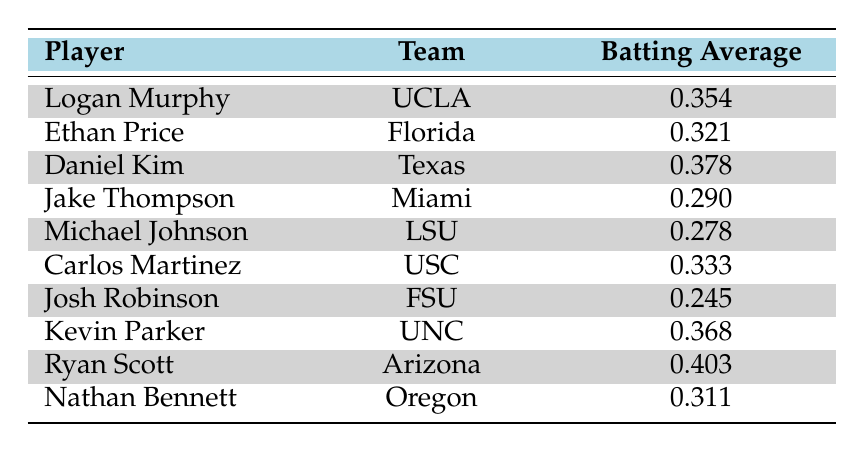What is the batting average of Ryan Scott? By looking at the "Player" column for Ryan Scott, the corresponding "Batting Average" found in the same row is 0.403.
Answer: 0.403 Which player has the highest batting average? Scanning through the "Batting Average" column, Ryan Scott has the highest value at 0.403.
Answer: Ryan Scott How many players have a batting average above 0.300? Counting the values in the "Batting Average" column, the players with averages above 0.300 are Logan Murphy (0.354), Daniel Kim (0.378), Carlos Martinez (0.333), Kevin Parker (0.368), Nathan Bennett (0.311), and Ryan Scott (0.403) — a total of 6 players.
Answer: 6 What is the difference between the highest and lowest batting average in this table? The highest batting average is 0.403 (Ryan Scott), and the lowest is 0.245 (Josh Robinson). Subtracting the lowest from the highest gives 0.403 - 0.245 = 0.158.
Answer: 0.158 Is Carlos Martinez's batting average higher than Michael Johnson's? Carlos Martinez's average is 0.333, while Michael Johnson's is 0.278. Since 0.333 is greater than 0.278, the statement is true.
Answer: Yes What is the average batting average of the players listed in the table? To find the average, sum all batting averages: (0.354 + 0.321 + 0.378 + 0.290 + 0.278 + 0.333 + 0.245 + 0.368 + 0.403 + 0.311) = 3.287. There are 10 players, so divide the total by 10: 3.287 / 10 = 0.3287.
Answer: 0.3287 Which team does Ethan Price play for? By checking the "Player" column for Ethan Price, we observe that his corresponding team is Florida.
Answer: Florida How many players have batting averages between 0.300 and 0.370? Filtering the batting averages, the players within this range are Logan Murphy (0.354), Ethan Price (0.321), Carlos Martinez (0.333), and Nathan Bennett (0.311), totaling 4 players.
Answer: 4 